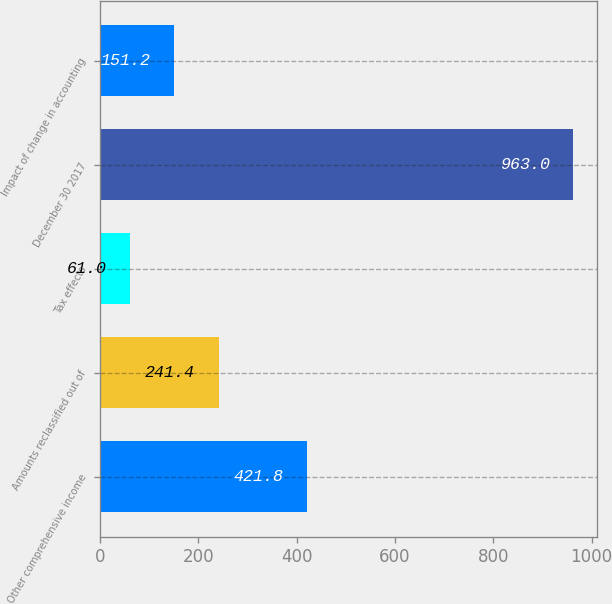Convert chart. <chart><loc_0><loc_0><loc_500><loc_500><bar_chart><fcel>Other comprehensive income<fcel>Amounts reclassified out of<fcel>Tax effects<fcel>December 30 2017<fcel>Impact of change in accounting<nl><fcel>421.8<fcel>241.4<fcel>61<fcel>963<fcel>151.2<nl></chart> 